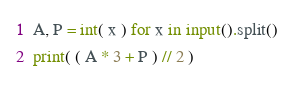<code> <loc_0><loc_0><loc_500><loc_500><_Python_>A, P = int( x ) for x in input().split()
print( ( A * 3 + P ) // 2 )</code> 